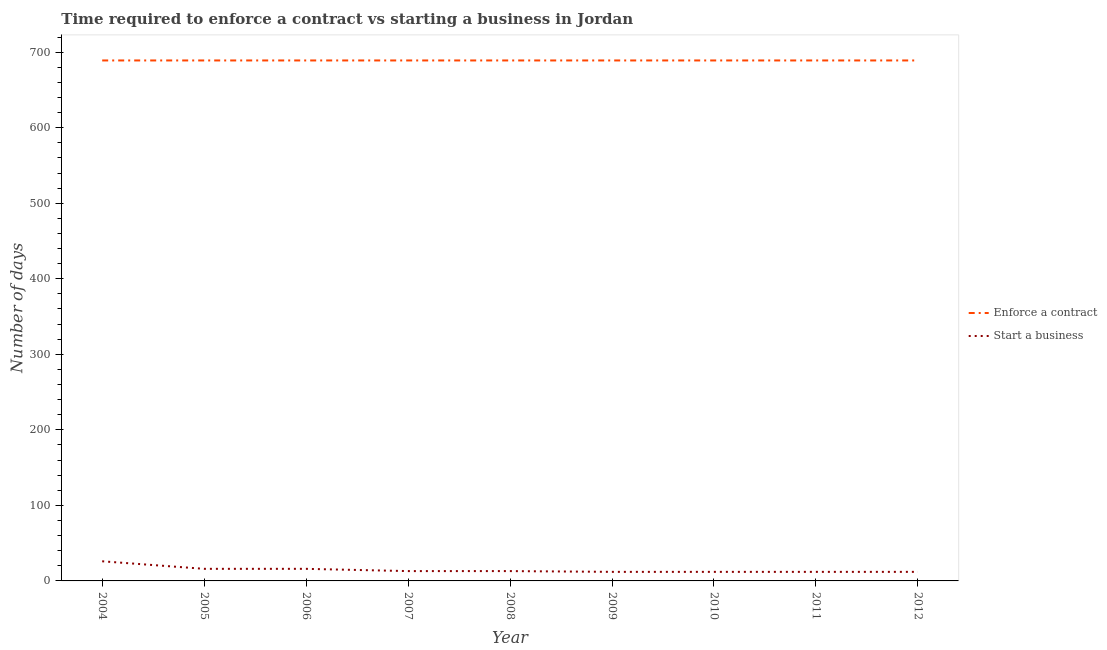How many different coloured lines are there?
Provide a succinct answer. 2. Does the line corresponding to number of days to enforece a contract intersect with the line corresponding to number of days to start a business?
Make the answer very short. No. What is the number of days to start a business in 2005?
Your response must be concise. 16. Across all years, what is the maximum number of days to start a business?
Your answer should be very brief. 26. Across all years, what is the minimum number of days to enforece a contract?
Your response must be concise. 689. In which year was the number of days to enforece a contract maximum?
Offer a very short reply. 2004. What is the total number of days to start a business in the graph?
Offer a terse response. 132. What is the difference between the number of days to start a business in 2008 and that in 2012?
Ensure brevity in your answer.  1. What is the difference between the number of days to start a business in 2011 and the number of days to enforece a contract in 2005?
Offer a terse response. -677. What is the average number of days to enforece a contract per year?
Give a very brief answer. 689. In the year 2011, what is the difference between the number of days to enforece a contract and number of days to start a business?
Provide a short and direct response. 677. What is the ratio of the number of days to start a business in 2005 to that in 2012?
Offer a very short reply. 1.33. Is the difference between the number of days to enforece a contract in 2008 and 2012 greater than the difference between the number of days to start a business in 2008 and 2012?
Provide a succinct answer. No. What is the difference between the highest and the lowest number of days to start a business?
Ensure brevity in your answer.  14. Is the sum of the number of days to start a business in 2004 and 2009 greater than the maximum number of days to enforece a contract across all years?
Offer a very short reply. No. Is the number of days to enforece a contract strictly greater than the number of days to start a business over the years?
Provide a succinct answer. Yes. Is the number of days to start a business strictly less than the number of days to enforece a contract over the years?
Your answer should be very brief. Yes. What is the difference between two consecutive major ticks on the Y-axis?
Provide a succinct answer. 100. Does the graph contain any zero values?
Provide a short and direct response. No. Does the graph contain grids?
Your answer should be compact. No. What is the title of the graph?
Your response must be concise. Time required to enforce a contract vs starting a business in Jordan. What is the label or title of the Y-axis?
Your answer should be compact. Number of days. What is the Number of days of Enforce a contract in 2004?
Your answer should be very brief. 689. What is the Number of days of Start a business in 2004?
Ensure brevity in your answer.  26. What is the Number of days in Enforce a contract in 2005?
Keep it short and to the point. 689. What is the Number of days in Enforce a contract in 2006?
Keep it short and to the point. 689. What is the Number of days in Start a business in 2006?
Your answer should be compact. 16. What is the Number of days in Enforce a contract in 2007?
Offer a terse response. 689. What is the Number of days of Start a business in 2007?
Your answer should be compact. 13. What is the Number of days of Enforce a contract in 2008?
Give a very brief answer. 689. What is the Number of days in Start a business in 2008?
Provide a succinct answer. 13. What is the Number of days in Enforce a contract in 2009?
Ensure brevity in your answer.  689. What is the Number of days of Enforce a contract in 2010?
Give a very brief answer. 689. What is the Number of days in Enforce a contract in 2011?
Give a very brief answer. 689. What is the Number of days of Start a business in 2011?
Your response must be concise. 12. What is the Number of days in Enforce a contract in 2012?
Keep it short and to the point. 689. Across all years, what is the maximum Number of days in Enforce a contract?
Give a very brief answer. 689. Across all years, what is the minimum Number of days in Enforce a contract?
Give a very brief answer. 689. What is the total Number of days in Enforce a contract in the graph?
Make the answer very short. 6201. What is the total Number of days in Start a business in the graph?
Your response must be concise. 132. What is the difference between the Number of days in Enforce a contract in 2004 and that in 2005?
Ensure brevity in your answer.  0. What is the difference between the Number of days of Start a business in 2004 and that in 2005?
Ensure brevity in your answer.  10. What is the difference between the Number of days in Enforce a contract in 2004 and that in 2007?
Your answer should be compact. 0. What is the difference between the Number of days of Start a business in 2004 and that in 2007?
Provide a succinct answer. 13. What is the difference between the Number of days in Enforce a contract in 2004 and that in 2008?
Give a very brief answer. 0. What is the difference between the Number of days in Start a business in 2004 and that in 2008?
Your response must be concise. 13. What is the difference between the Number of days of Start a business in 2004 and that in 2009?
Offer a terse response. 14. What is the difference between the Number of days of Enforce a contract in 2004 and that in 2011?
Provide a succinct answer. 0. What is the difference between the Number of days of Start a business in 2004 and that in 2011?
Offer a very short reply. 14. What is the difference between the Number of days in Enforce a contract in 2004 and that in 2012?
Your answer should be very brief. 0. What is the difference between the Number of days in Start a business in 2004 and that in 2012?
Your answer should be very brief. 14. What is the difference between the Number of days in Enforce a contract in 2005 and that in 2006?
Make the answer very short. 0. What is the difference between the Number of days of Start a business in 2005 and that in 2006?
Ensure brevity in your answer.  0. What is the difference between the Number of days in Enforce a contract in 2005 and that in 2007?
Provide a succinct answer. 0. What is the difference between the Number of days of Start a business in 2005 and that in 2007?
Make the answer very short. 3. What is the difference between the Number of days in Enforce a contract in 2005 and that in 2008?
Your answer should be compact. 0. What is the difference between the Number of days in Start a business in 2005 and that in 2008?
Provide a short and direct response. 3. What is the difference between the Number of days of Enforce a contract in 2005 and that in 2009?
Make the answer very short. 0. What is the difference between the Number of days of Start a business in 2005 and that in 2009?
Offer a terse response. 4. What is the difference between the Number of days of Enforce a contract in 2005 and that in 2011?
Give a very brief answer. 0. What is the difference between the Number of days of Enforce a contract in 2005 and that in 2012?
Your answer should be compact. 0. What is the difference between the Number of days of Start a business in 2005 and that in 2012?
Offer a terse response. 4. What is the difference between the Number of days of Enforce a contract in 2006 and that in 2007?
Your answer should be compact. 0. What is the difference between the Number of days of Enforce a contract in 2006 and that in 2008?
Give a very brief answer. 0. What is the difference between the Number of days in Start a business in 2006 and that in 2008?
Provide a succinct answer. 3. What is the difference between the Number of days of Enforce a contract in 2006 and that in 2009?
Your answer should be very brief. 0. What is the difference between the Number of days in Enforce a contract in 2006 and that in 2010?
Make the answer very short. 0. What is the difference between the Number of days in Start a business in 2006 and that in 2010?
Your response must be concise. 4. What is the difference between the Number of days of Start a business in 2006 and that in 2011?
Your answer should be very brief. 4. What is the difference between the Number of days in Enforce a contract in 2006 and that in 2012?
Your answer should be compact. 0. What is the difference between the Number of days of Enforce a contract in 2007 and that in 2008?
Offer a very short reply. 0. What is the difference between the Number of days in Start a business in 2007 and that in 2008?
Provide a short and direct response. 0. What is the difference between the Number of days of Start a business in 2007 and that in 2010?
Provide a short and direct response. 1. What is the difference between the Number of days of Start a business in 2007 and that in 2011?
Make the answer very short. 1. What is the difference between the Number of days of Enforce a contract in 2007 and that in 2012?
Keep it short and to the point. 0. What is the difference between the Number of days in Start a business in 2007 and that in 2012?
Make the answer very short. 1. What is the difference between the Number of days in Enforce a contract in 2008 and that in 2010?
Offer a terse response. 0. What is the difference between the Number of days in Start a business in 2009 and that in 2010?
Offer a terse response. 0. What is the difference between the Number of days of Enforce a contract in 2009 and that in 2011?
Give a very brief answer. 0. What is the difference between the Number of days of Enforce a contract in 2009 and that in 2012?
Make the answer very short. 0. What is the difference between the Number of days in Enforce a contract in 2010 and that in 2011?
Your answer should be compact. 0. What is the difference between the Number of days of Enforce a contract in 2010 and that in 2012?
Provide a succinct answer. 0. What is the difference between the Number of days in Start a business in 2010 and that in 2012?
Give a very brief answer. 0. What is the difference between the Number of days of Enforce a contract in 2011 and that in 2012?
Offer a terse response. 0. What is the difference between the Number of days in Start a business in 2011 and that in 2012?
Offer a very short reply. 0. What is the difference between the Number of days in Enforce a contract in 2004 and the Number of days in Start a business in 2005?
Give a very brief answer. 673. What is the difference between the Number of days of Enforce a contract in 2004 and the Number of days of Start a business in 2006?
Your response must be concise. 673. What is the difference between the Number of days of Enforce a contract in 2004 and the Number of days of Start a business in 2007?
Your answer should be compact. 676. What is the difference between the Number of days of Enforce a contract in 2004 and the Number of days of Start a business in 2008?
Offer a very short reply. 676. What is the difference between the Number of days in Enforce a contract in 2004 and the Number of days in Start a business in 2009?
Your response must be concise. 677. What is the difference between the Number of days in Enforce a contract in 2004 and the Number of days in Start a business in 2010?
Ensure brevity in your answer.  677. What is the difference between the Number of days in Enforce a contract in 2004 and the Number of days in Start a business in 2011?
Offer a very short reply. 677. What is the difference between the Number of days of Enforce a contract in 2004 and the Number of days of Start a business in 2012?
Your answer should be very brief. 677. What is the difference between the Number of days in Enforce a contract in 2005 and the Number of days in Start a business in 2006?
Offer a very short reply. 673. What is the difference between the Number of days of Enforce a contract in 2005 and the Number of days of Start a business in 2007?
Offer a very short reply. 676. What is the difference between the Number of days of Enforce a contract in 2005 and the Number of days of Start a business in 2008?
Make the answer very short. 676. What is the difference between the Number of days in Enforce a contract in 2005 and the Number of days in Start a business in 2009?
Provide a short and direct response. 677. What is the difference between the Number of days of Enforce a contract in 2005 and the Number of days of Start a business in 2010?
Make the answer very short. 677. What is the difference between the Number of days of Enforce a contract in 2005 and the Number of days of Start a business in 2011?
Offer a very short reply. 677. What is the difference between the Number of days in Enforce a contract in 2005 and the Number of days in Start a business in 2012?
Give a very brief answer. 677. What is the difference between the Number of days in Enforce a contract in 2006 and the Number of days in Start a business in 2007?
Your answer should be very brief. 676. What is the difference between the Number of days of Enforce a contract in 2006 and the Number of days of Start a business in 2008?
Offer a terse response. 676. What is the difference between the Number of days of Enforce a contract in 2006 and the Number of days of Start a business in 2009?
Provide a succinct answer. 677. What is the difference between the Number of days in Enforce a contract in 2006 and the Number of days in Start a business in 2010?
Your answer should be compact. 677. What is the difference between the Number of days in Enforce a contract in 2006 and the Number of days in Start a business in 2011?
Make the answer very short. 677. What is the difference between the Number of days in Enforce a contract in 2006 and the Number of days in Start a business in 2012?
Keep it short and to the point. 677. What is the difference between the Number of days of Enforce a contract in 2007 and the Number of days of Start a business in 2008?
Provide a short and direct response. 676. What is the difference between the Number of days of Enforce a contract in 2007 and the Number of days of Start a business in 2009?
Provide a succinct answer. 677. What is the difference between the Number of days in Enforce a contract in 2007 and the Number of days in Start a business in 2010?
Your answer should be compact. 677. What is the difference between the Number of days of Enforce a contract in 2007 and the Number of days of Start a business in 2011?
Provide a succinct answer. 677. What is the difference between the Number of days of Enforce a contract in 2007 and the Number of days of Start a business in 2012?
Your response must be concise. 677. What is the difference between the Number of days in Enforce a contract in 2008 and the Number of days in Start a business in 2009?
Offer a very short reply. 677. What is the difference between the Number of days in Enforce a contract in 2008 and the Number of days in Start a business in 2010?
Your answer should be very brief. 677. What is the difference between the Number of days of Enforce a contract in 2008 and the Number of days of Start a business in 2011?
Make the answer very short. 677. What is the difference between the Number of days of Enforce a contract in 2008 and the Number of days of Start a business in 2012?
Provide a short and direct response. 677. What is the difference between the Number of days of Enforce a contract in 2009 and the Number of days of Start a business in 2010?
Ensure brevity in your answer.  677. What is the difference between the Number of days of Enforce a contract in 2009 and the Number of days of Start a business in 2011?
Offer a terse response. 677. What is the difference between the Number of days of Enforce a contract in 2009 and the Number of days of Start a business in 2012?
Give a very brief answer. 677. What is the difference between the Number of days of Enforce a contract in 2010 and the Number of days of Start a business in 2011?
Offer a very short reply. 677. What is the difference between the Number of days of Enforce a contract in 2010 and the Number of days of Start a business in 2012?
Give a very brief answer. 677. What is the difference between the Number of days in Enforce a contract in 2011 and the Number of days in Start a business in 2012?
Ensure brevity in your answer.  677. What is the average Number of days in Enforce a contract per year?
Offer a very short reply. 689. What is the average Number of days of Start a business per year?
Provide a succinct answer. 14.67. In the year 2004, what is the difference between the Number of days of Enforce a contract and Number of days of Start a business?
Your response must be concise. 663. In the year 2005, what is the difference between the Number of days in Enforce a contract and Number of days in Start a business?
Your answer should be very brief. 673. In the year 2006, what is the difference between the Number of days in Enforce a contract and Number of days in Start a business?
Give a very brief answer. 673. In the year 2007, what is the difference between the Number of days of Enforce a contract and Number of days of Start a business?
Give a very brief answer. 676. In the year 2008, what is the difference between the Number of days in Enforce a contract and Number of days in Start a business?
Provide a short and direct response. 676. In the year 2009, what is the difference between the Number of days of Enforce a contract and Number of days of Start a business?
Offer a very short reply. 677. In the year 2010, what is the difference between the Number of days of Enforce a contract and Number of days of Start a business?
Make the answer very short. 677. In the year 2011, what is the difference between the Number of days of Enforce a contract and Number of days of Start a business?
Your response must be concise. 677. In the year 2012, what is the difference between the Number of days of Enforce a contract and Number of days of Start a business?
Provide a succinct answer. 677. What is the ratio of the Number of days in Enforce a contract in 2004 to that in 2005?
Offer a very short reply. 1. What is the ratio of the Number of days of Start a business in 2004 to that in 2005?
Offer a very short reply. 1.62. What is the ratio of the Number of days in Enforce a contract in 2004 to that in 2006?
Make the answer very short. 1. What is the ratio of the Number of days in Start a business in 2004 to that in 2006?
Your answer should be very brief. 1.62. What is the ratio of the Number of days in Start a business in 2004 to that in 2008?
Your response must be concise. 2. What is the ratio of the Number of days in Enforce a contract in 2004 to that in 2009?
Your answer should be compact. 1. What is the ratio of the Number of days in Start a business in 2004 to that in 2009?
Your answer should be compact. 2.17. What is the ratio of the Number of days of Start a business in 2004 to that in 2010?
Ensure brevity in your answer.  2.17. What is the ratio of the Number of days of Enforce a contract in 2004 to that in 2011?
Provide a short and direct response. 1. What is the ratio of the Number of days of Start a business in 2004 to that in 2011?
Ensure brevity in your answer.  2.17. What is the ratio of the Number of days of Start a business in 2004 to that in 2012?
Make the answer very short. 2.17. What is the ratio of the Number of days of Enforce a contract in 2005 to that in 2006?
Your answer should be very brief. 1. What is the ratio of the Number of days of Enforce a contract in 2005 to that in 2007?
Make the answer very short. 1. What is the ratio of the Number of days in Start a business in 2005 to that in 2007?
Offer a terse response. 1.23. What is the ratio of the Number of days of Start a business in 2005 to that in 2008?
Provide a succinct answer. 1.23. What is the ratio of the Number of days of Enforce a contract in 2005 to that in 2009?
Your answer should be very brief. 1. What is the ratio of the Number of days of Enforce a contract in 2005 to that in 2011?
Ensure brevity in your answer.  1. What is the ratio of the Number of days in Start a business in 2005 to that in 2011?
Make the answer very short. 1.33. What is the ratio of the Number of days of Start a business in 2006 to that in 2007?
Offer a very short reply. 1.23. What is the ratio of the Number of days of Enforce a contract in 2006 to that in 2008?
Make the answer very short. 1. What is the ratio of the Number of days in Start a business in 2006 to that in 2008?
Offer a very short reply. 1.23. What is the ratio of the Number of days in Enforce a contract in 2006 to that in 2009?
Provide a short and direct response. 1. What is the ratio of the Number of days in Enforce a contract in 2006 to that in 2010?
Your response must be concise. 1. What is the ratio of the Number of days of Enforce a contract in 2006 to that in 2012?
Offer a very short reply. 1. What is the ratio of the Number of days in Start a business in 2006 to that in 2012?
Ensure brevity in your answer.  1.33. What is the ratio of the Number of days in Enforce a contract in 2007 to that in 2009?
Offer a very short reply. 1. What is the ratio of the Number of days in Enforce a contract in 2007 to that in 2010?
Provide a short and direct response. 1. What is the ratio of the Number of days in Start a business in 2007 to that in 2010?
Your response must be concise. 1.08. What is the ratio of the Number of days in Enforce a contract in 2007 to that in 2011?
Offer a terse response. 1. What is the ratio of the Number of days of Start a business in 2007 to that in 2011?
Your answer should be very brief. 1.08. What is the ratio of the Number of days in Enforce a contract in 2007 to that in 2012?
Ensure brevity in your answer.  1. What is the ratio of the Number of days of Start a business in 2007 to that in 2012?
Provide a succinct answer. 1.08. What is the ratio of the Number of days of Enforce a contract in 2008 to that in 2012?
Make the answer very short. 1. What is the ratio of the Number of days of Start a business in 2009 to that in 2010?
Offer a terse response. 1. What is the ratio of the Number of days of Start a business in 2009 to that in 2011?
Your answer should be very brief. 1. What is the ratio of the Number of days of Start a business in 2009 to that in 2012?
Your response must be concise. 1. What is the ratio of the Number of days of Enforce a contract in 2010 to that in 2011?
Offer a terse response. 1. What is the difference between the highest and the second highest Number of days of Enforce a contract?
Give a very brief answer. 0. What is the difference between the highest and the second highest Number of days of Start a business?
Offer a very short reply. 10. What is the difference between the highest and the lowest Number of days in Enforce a contract?
Keep it short and to the point. 0. 